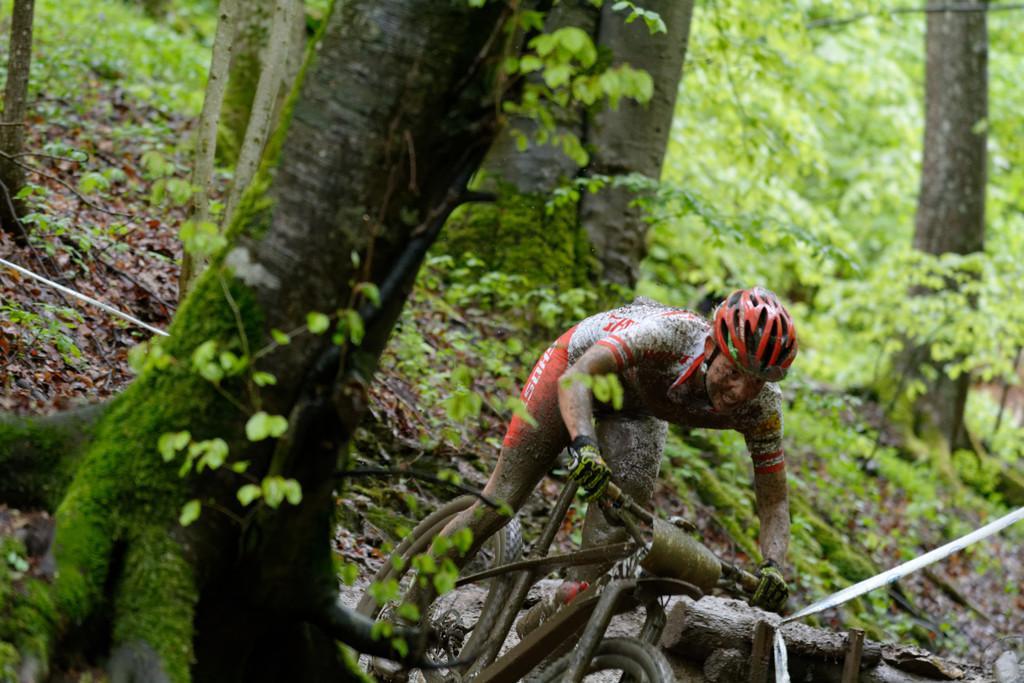Can you describe this image briefly? This picture shows a few trees and we see a man riding a bicycle and he wore a helmet on his head. 